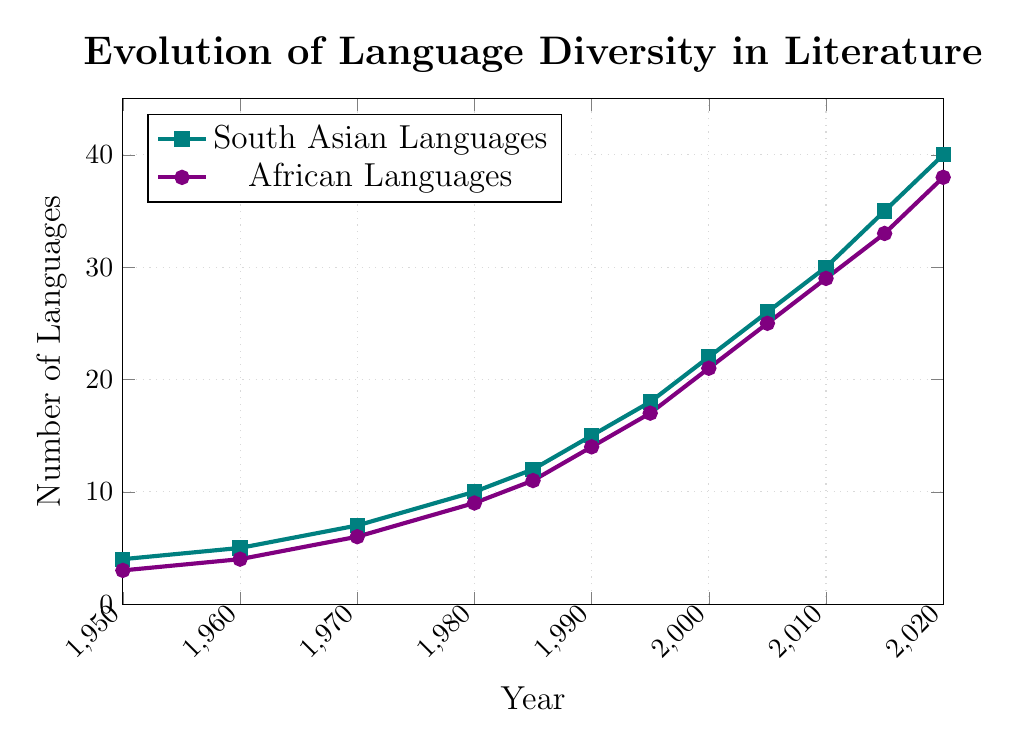What's the number of South Asian languages represented in 1990? Locate the point corresponding to the year 1990 on the x-axis and check the y-axis value for South Asian languages, indicated by a square marker in teal color. It shows 15 languages.
Answer: 15 Which region had a greater number of languages represented in the year 2000? Compare the data points for the year 2000. The South Asian languages have a value of 22 (teal squares) while the African languages have a value of 21 (purple dots). South Asian languages were higher.
Answer: South Asian countries How much did the number of African languages increase from 1950 to 2020? Find the values for African languages in 1950 and 2020: 3 in 1950 and 38 in 2020. Subtract the earlier value from the later value: 38 - 3 = 35.
Answer: 35 In which year did the number of South Asian languages exceed 20? Locate the year on the x-axis where the South Asian language representation first surpasses 20. It happens in the year 2000 (22 languages).
Answer: 2000 What is the difference between the number of South Asian and African languages in 2010? Find the values for both regions in the year 2010: South Asian languages are 30 and African languages are 29. The difference is 30 - 29 = 1.
Answer: 1 What is the average number of African languages represented over the years 1985, 1990, and 1995? Sum the values for African languages in the years 1985 (11), 1990 (14), and 1995 (17): 11 + 14 + 17 = 42. Divide by 3 to find the average: 42 / 3 = 14.
Answer: 14 Which year saw the fastest increase in the number of South Asian languages? Identify the year with the steepest slope for South Asian languages. Comparing intervals, the most significant jump happens between 2000 (22) and 2005 (26), an increase of 4. Other periods with a larger increase are between 2015 (35) and 2020 (40), which is an increase of 5.
Answer: 2015-2020 How do the trends in language diversity in South Asian and African literature compare between 1970 and 1985? Observe both lines between 1970 and 1985. South Asian languages increase from 7 to 12 (a difference of 5), while African languages rise from 6 to 11 (a difference of 5). Both regions show an equal increase in language diversity during this period.
Answer: Equal increase What’s the ratio of South Asian languages to African languages in 2020? Look at the values for 2020: South Asian languages are 40, and African languages are 38. The ratio is 40:38, which simplifies to 20:19.
Answer: 20:19 